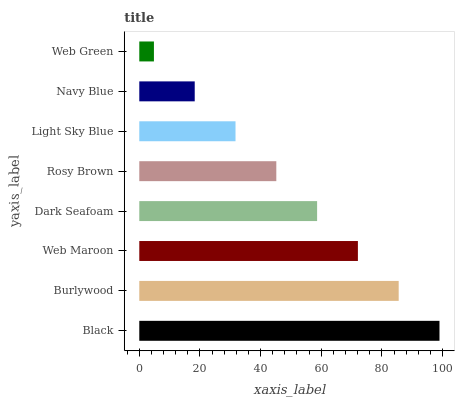Is Web Green the minimum?
Answer yes or no. Yes. Is Black the maximum?
Answer yes or no. Yes. Is Burlywood the minimum?
Answer yes or no. No. Is Burlywood the maximum?
Answer yes or no. No. Is Black greater than Burlywood?
Answer yes or no. Yes. Is Burlywood less than Black?
Answer yes or no. Yes. Is Burlywood greater than Black?
Answer yes or no. No. Is Black less than Burlywood?
Answer yes or no. No. Is Dark Seafoam the high median?
Answer yes or no. Yes. Is Rosy Brown the low median?
Answer yes or no. Yes. Is Web Maroon the high median?
Answer yes or no. No. Is Navy Blue the low median?
Answer yes or no. No. 